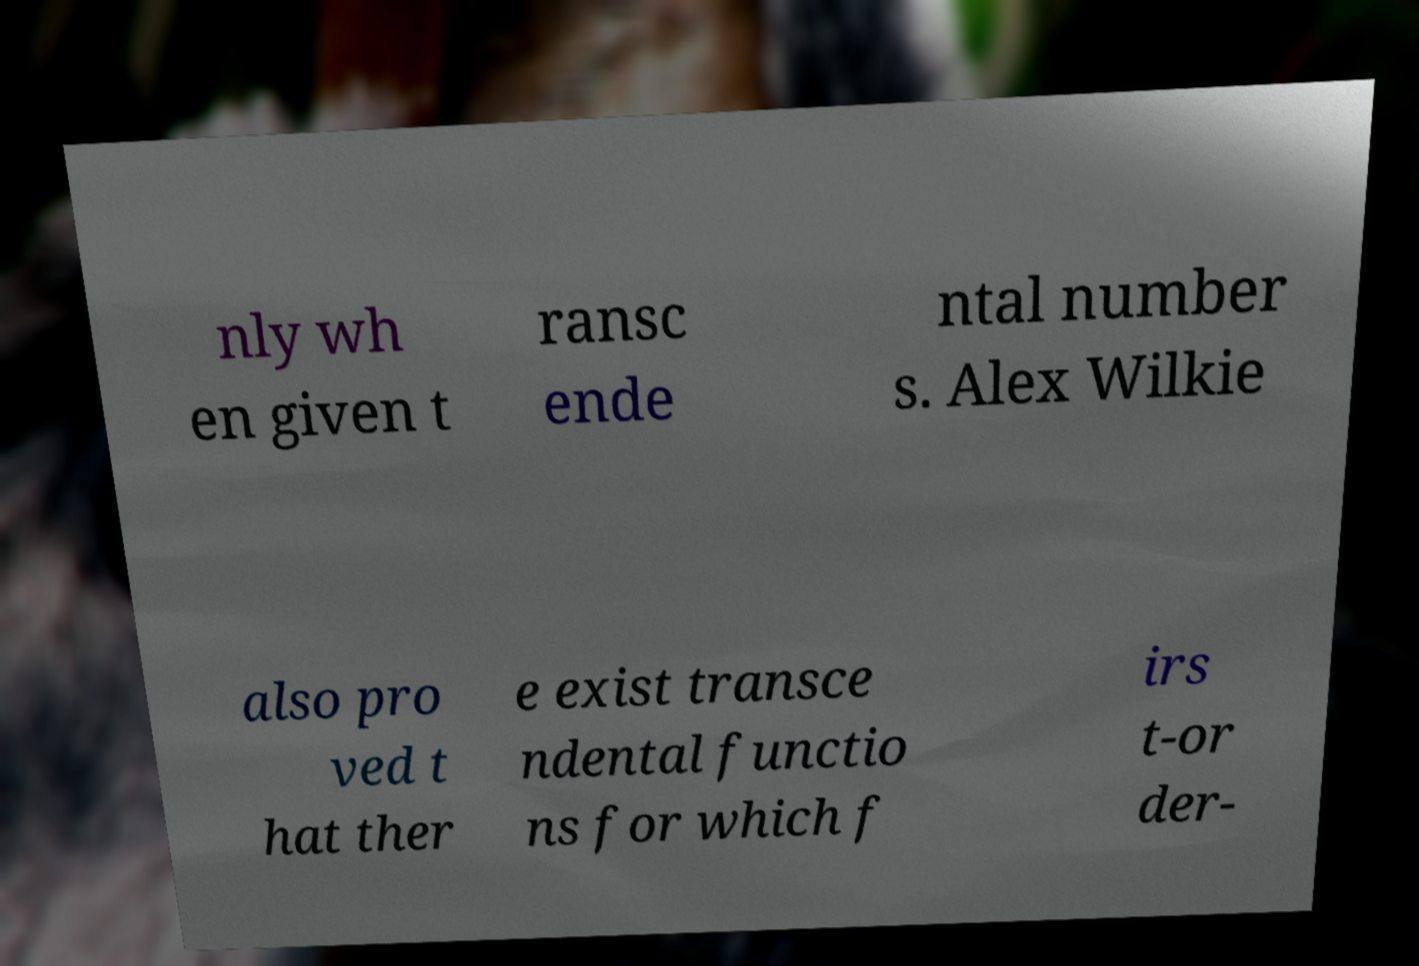I need the written content from this picture converted into text. Can you do that? nly wh en given t ransc ende ntal number s. Alex Wilkie also pro ved t hat ther e exist transce ndental functio ns for which f irs t-or der- 